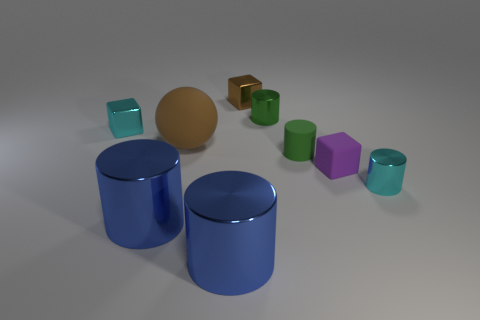Is the color of the ball the same as the tiny matte block?
Your answer should be very brief. No. Is the material of the sphere the same as the large cylinder that is to the right of the matte ball?
Give a very brief answer. No. What is the color of the large ball?
Provide a short and direct response. Brown. What is the size of the brown object that is made of the same material as the small purple block?
Offer a terse response. Large. What number of tiny cyan objects are in front of the tiny green object in front of the shiny cylinder behind the small matte cube?
Give a very brief answer. 1. Do the big rubber object and the large thing left of the brown matte object have the same color?
Offer a very short reply. No. The shiny object that is the same color as the tiny rubber cylinder is what shape?
Your answer should be compact. Cylinder. There is a green cylinder that is behind the cyan object that is behind the small shiny cylinder that is in front of the tiny green metallic cylinder; what is it made of?
Provide a succinct answer. Metal. Is the shape of the purple matte thing in front of the cyan metallic block the same as  the brown matte object?
Ensure brevity in your answer.  No. What material is the tiny cyan object that is behind the cyan cylinder?
Offer a terse response. Metal. 